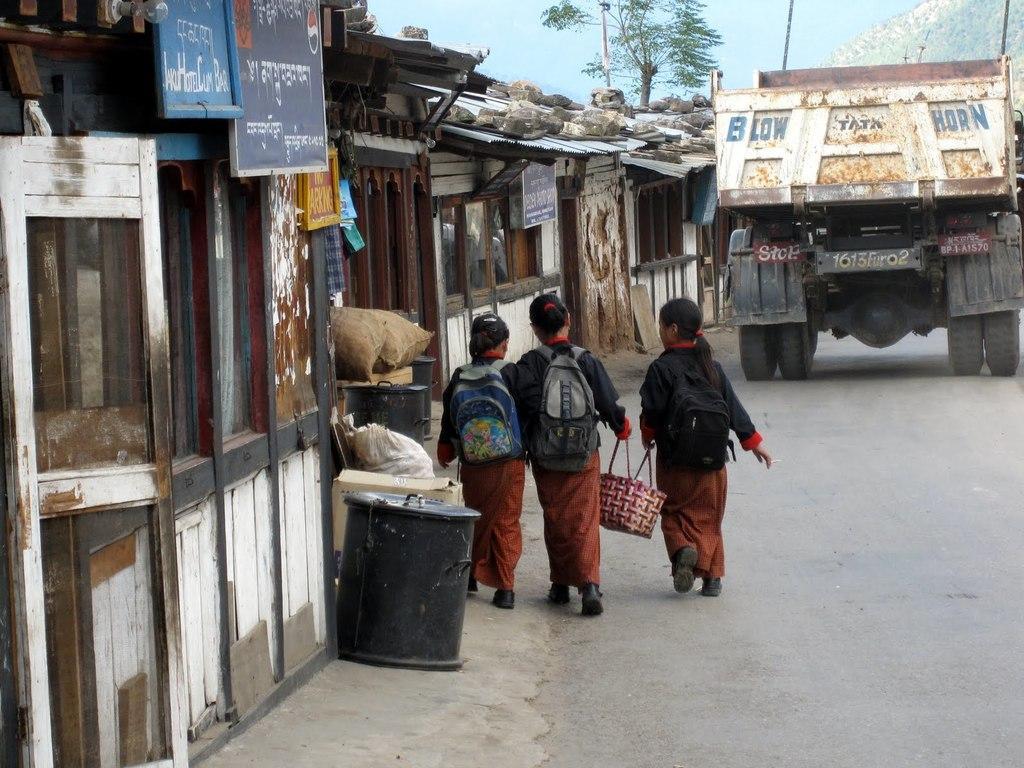Can you describe this image briefly? In this picture we can see houses with windows and banners. This houses are made of sheet and rocks are kept on this sheets and aside to this we have road and on road we can see a vehicle and three girls are walking on the road with carrying bags and a basket and above there is a tree,sky, hill. 